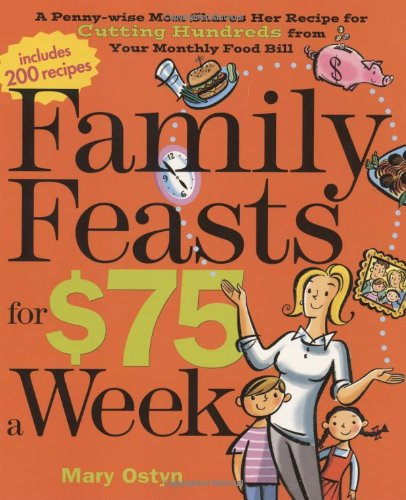Is this a crafts or hobbies related book? No, it is not related to crafts or hobbies. This book primarily focuses on recipes and strategies for reducing food expenditure. 